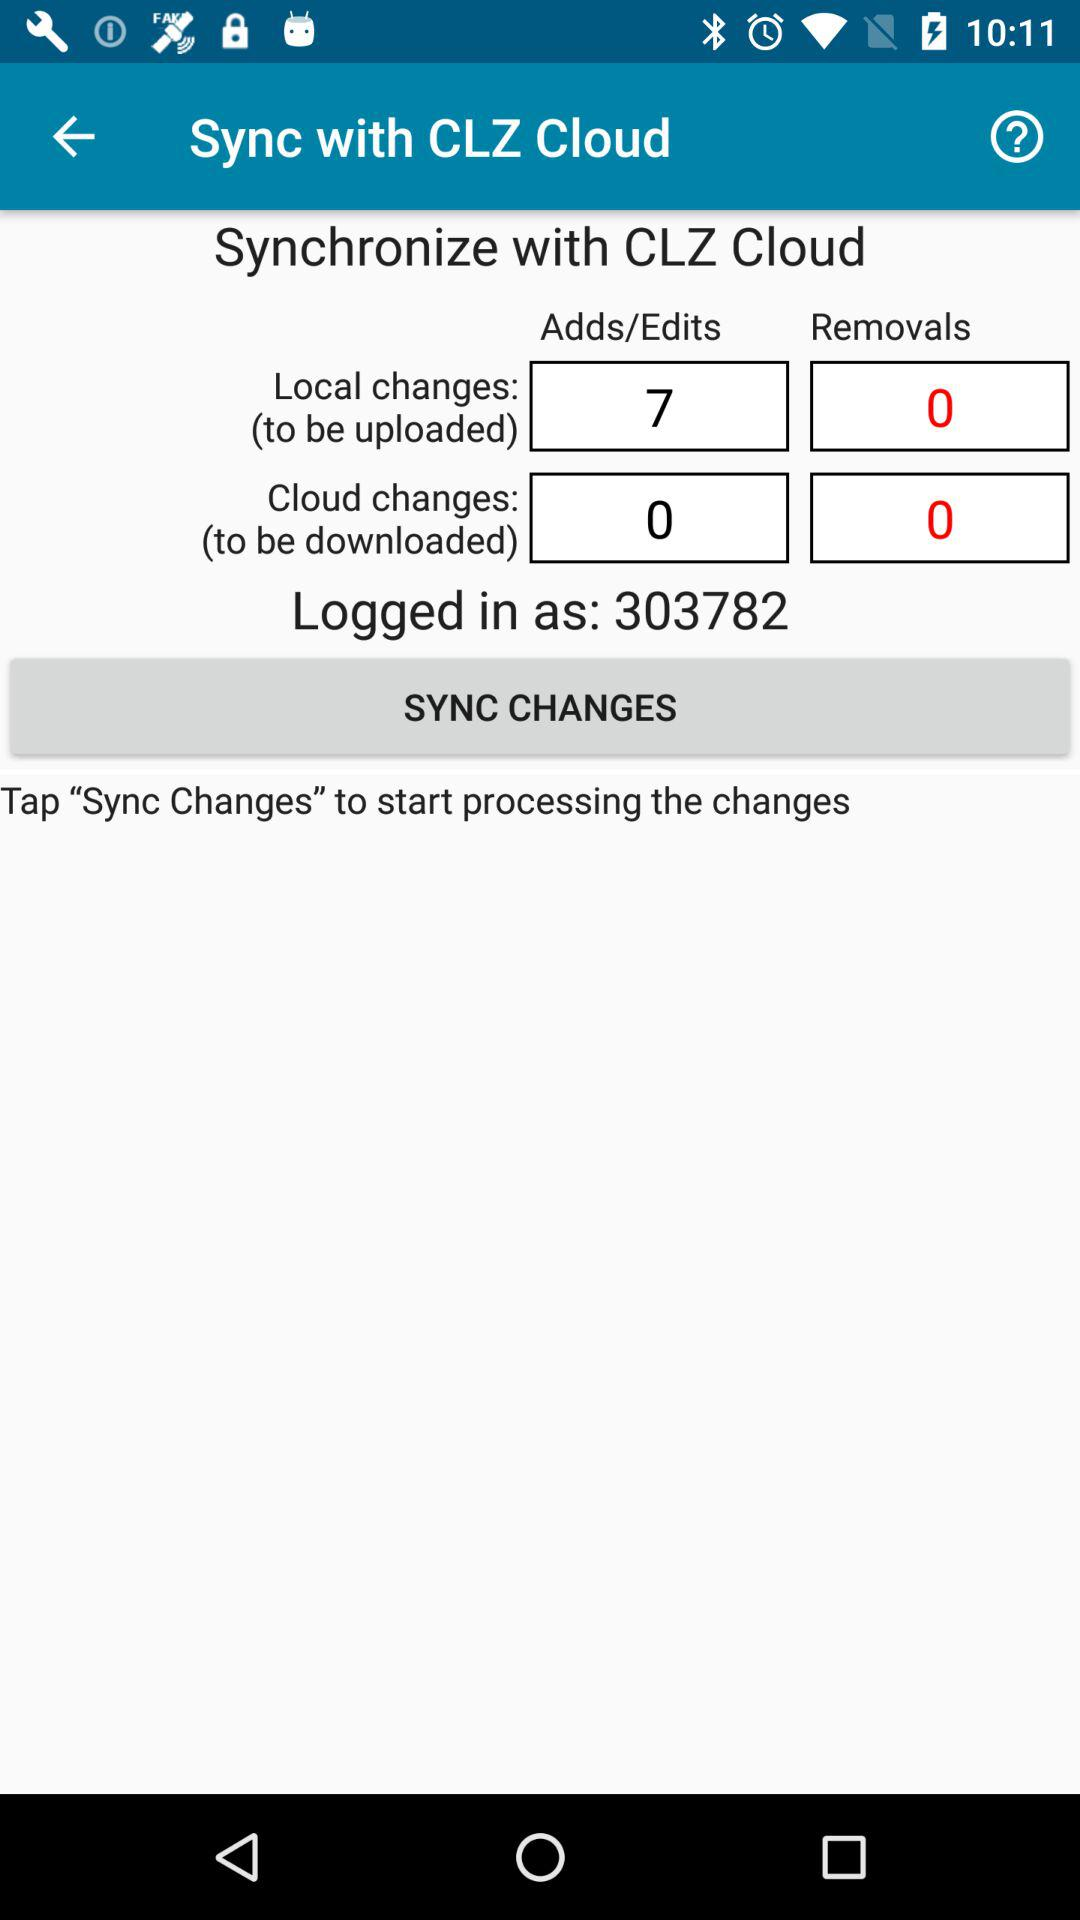What is the log in ID? The log in ID is 303782. 